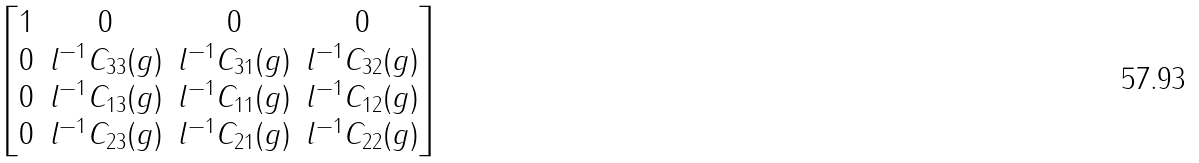<formula> <loc_0><loc_0><loc_500><loc_500>\begin{bmatrix} 1 & 0 & 0 & 0 \\ 0 & l ^ { - 1 } C _ { 3 3 } ( g ) & l ^ { - 1 } C _ { 3 1 } ( g ) & l ^ { - 1 } C _ { 3 2 } ( g ) \\ 0 & l ^ { - 1 } C _ { 1 3 } ( g ) & l ^ { - 1 } C _ { 1 1 } ( g ) & l ^ { - 1 } C _ { 1 2 } ( g ) \\ 0 & l ^ { - 1 } C _ { 2 3 } ( g ) & l ^ { - 1 } C _ { 2 1 } ( g ) & l ^ { - 1 } C _ { 2 2 } ( g ) \end{bmatrix}</formula> 